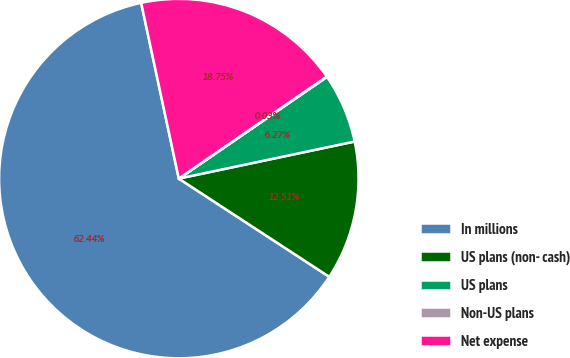<chart> <loc_0><loc_0><loc_500><loc_500><pie_chart><fcel>In millions<fcel>US plans (non- cash)<fcel>US plans<fcel>Non-US plans<fcel>Net expense<nl><fcel>62.43%<fcel>12.51%<fcel>6.27%<fcel>0.03%<fcel>18.75%<nl></chart> 